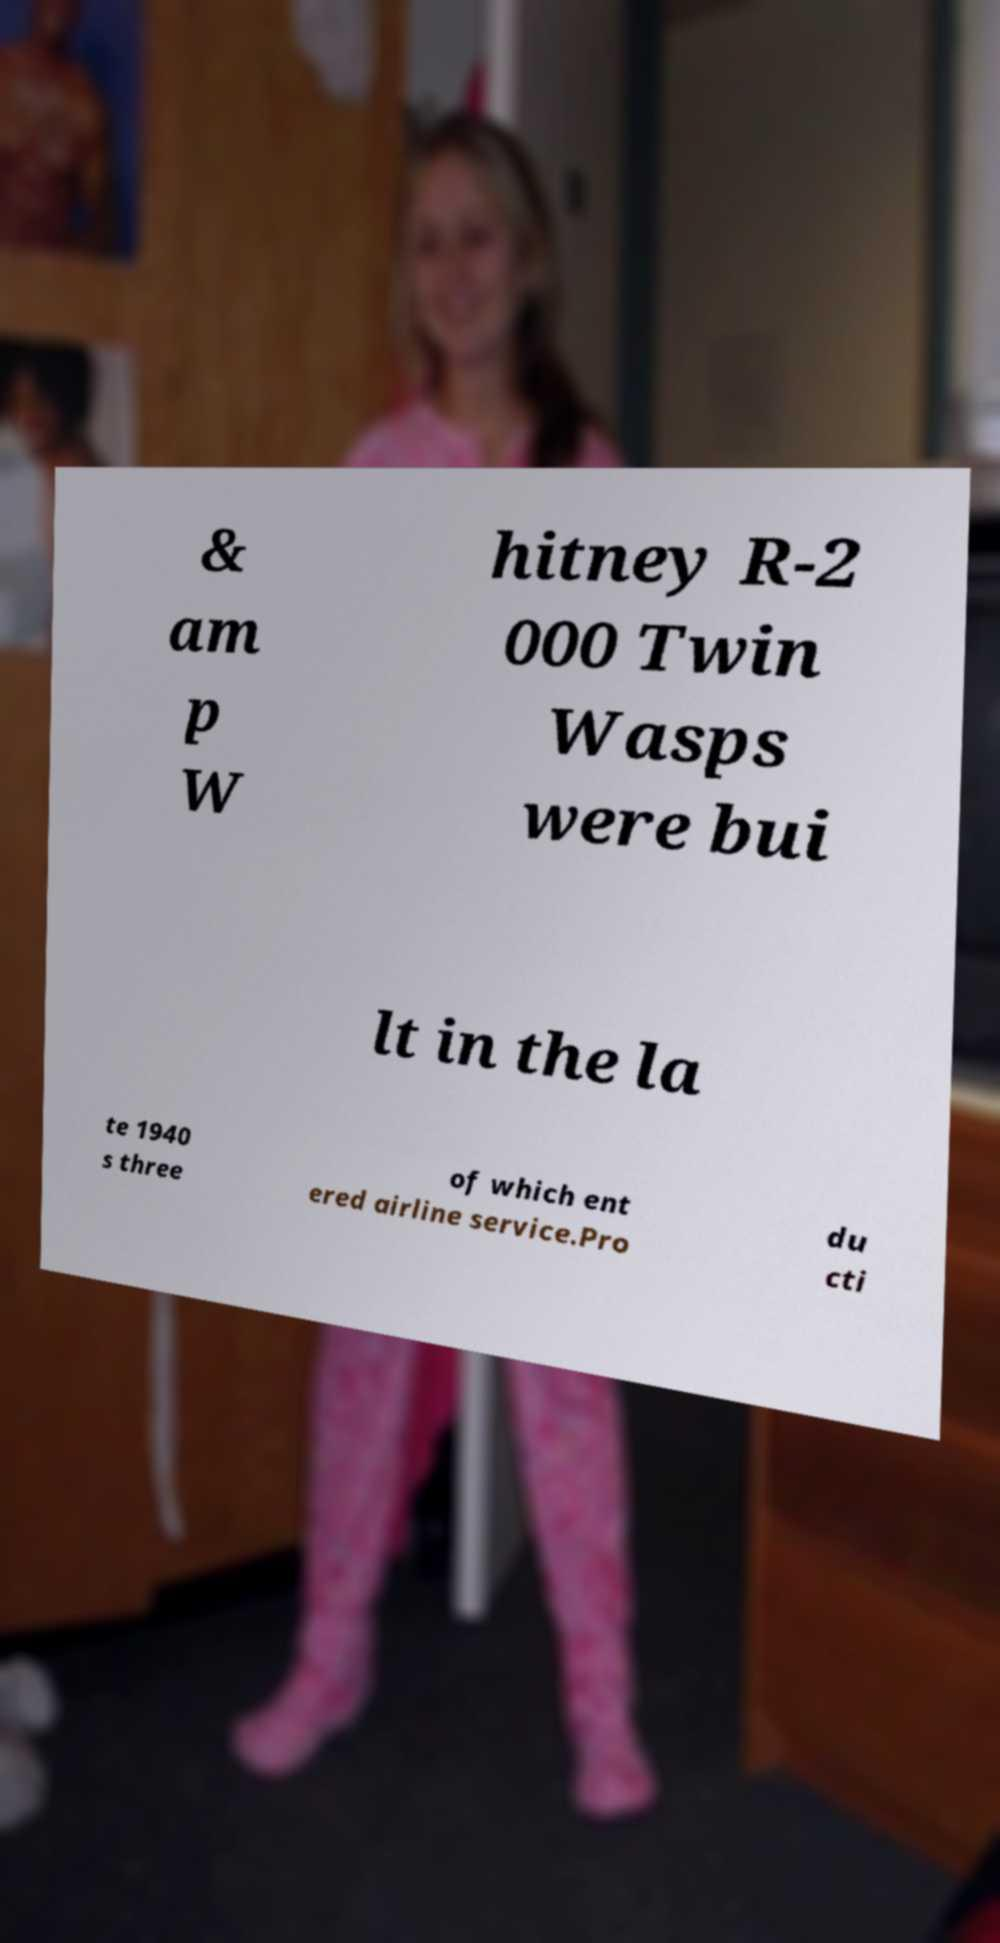Please identify and transcribe the text found in this image. & am p W hitney R-2 000 Twin Wasps were bui lt in the la te 1940 s three of which ent ered airline service.Pro du cti 